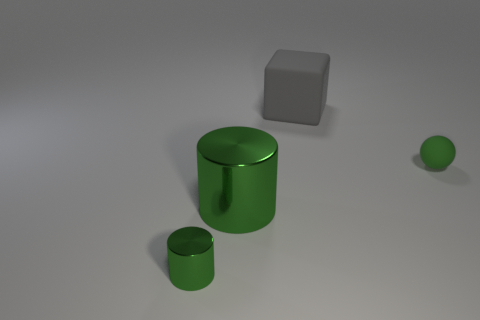Add 1 small cyan spheres. How many objects exist? 5 Subtract all balls. How many objects are left? 3 Add 1 big cylinders. How many big cylinders are left? 2 Add 2 large red matte balls. How many large red matte balls exist? 2 Subtract 0 purple cylinders. How many objects are left? 4 Subtract all cyan matte balls. Subtract all big matte things. How many objects are left? 3 